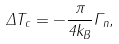<formula> <loc_0><loc_0><loc_500><loc_500>\Delta T _ { c } = - \frac { \pi } { 4 k _ { B } } \Gamma _ { n } ,</formula> 